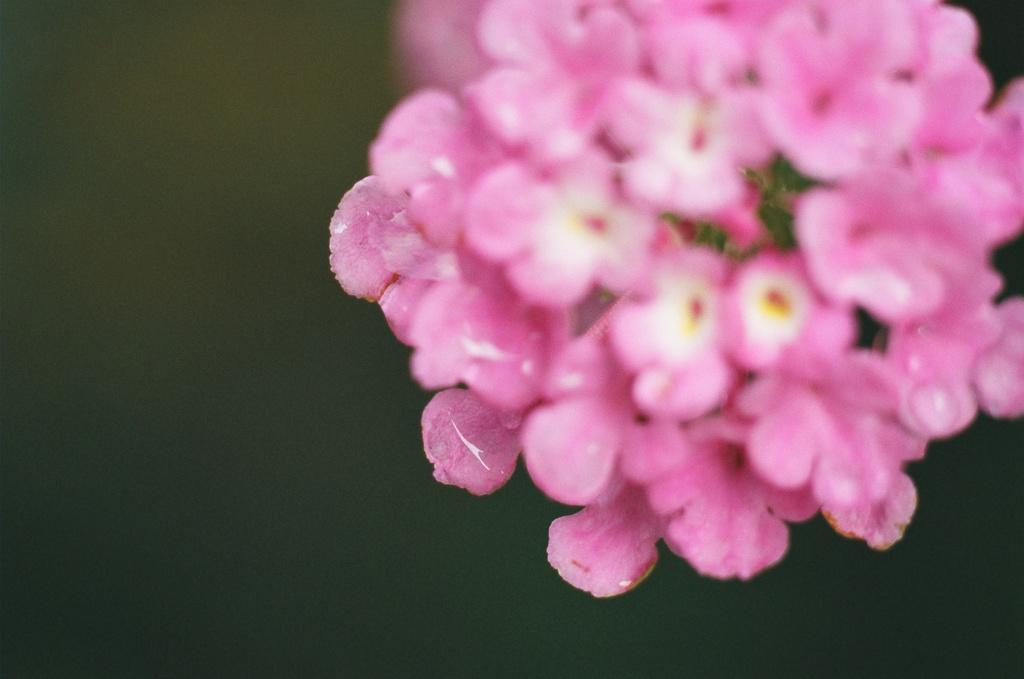How would you summarize this image in a sentence or two? We can see pink flowers. In the background it is blur. 